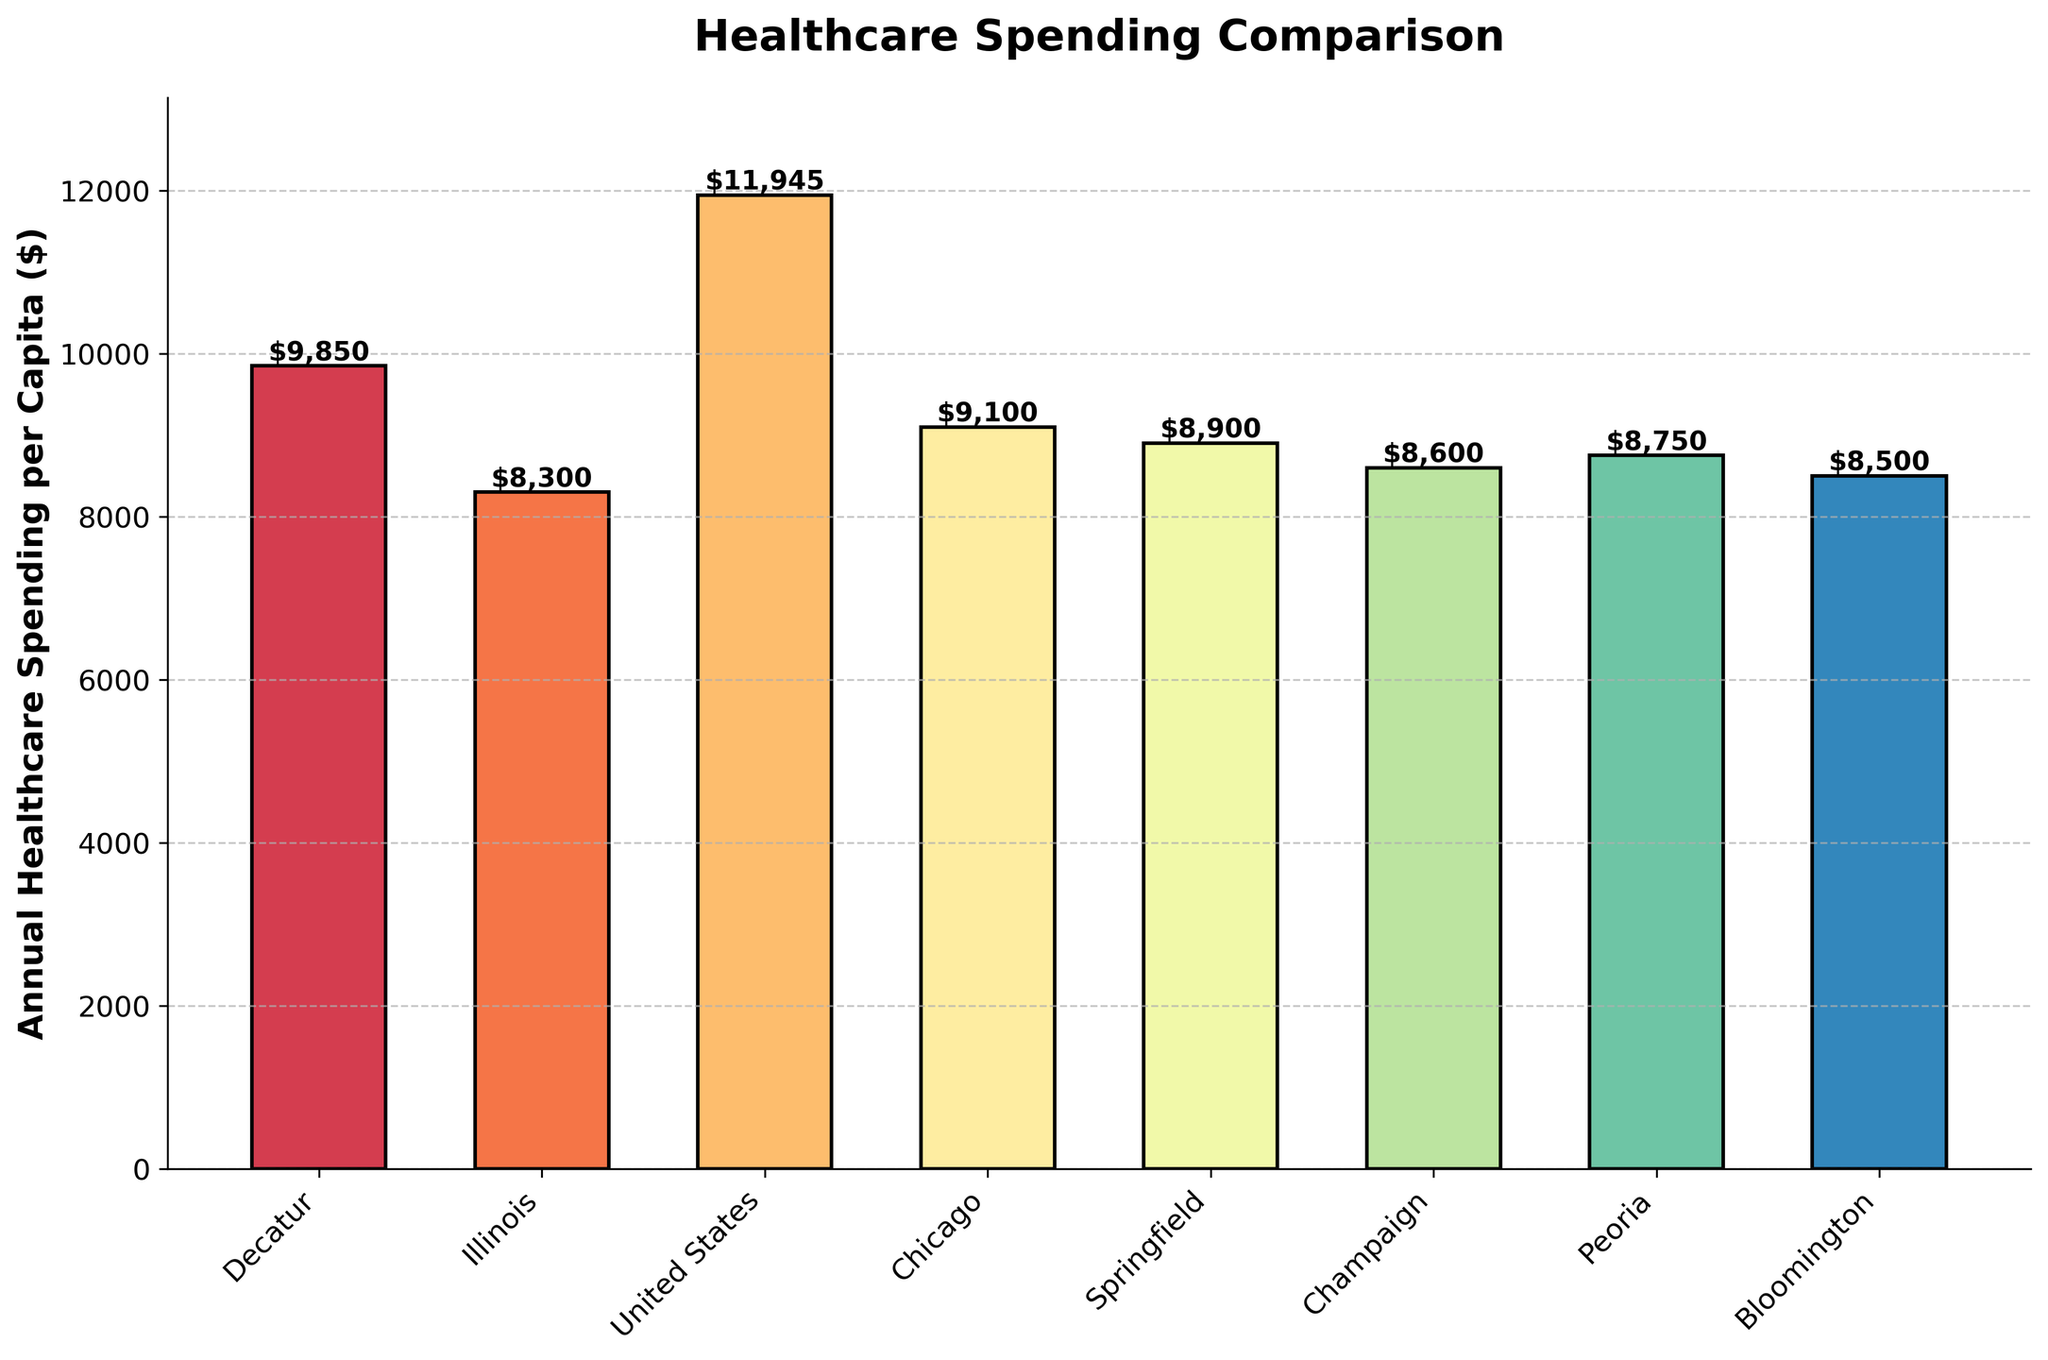What is the difference in annual healthcare spending per capita between Decatur and Illinois? To find the difference, subtract the spending in Illinois from the spending in Decatur: $9850 - $8300 = $1550
Answer: $1550 How does the annual healthcare spending per capita in Decatur compare to the national average? The spending in Decatur is $9850, while the national average is $11945. Subtract the former from the latter to find the difference: $9850 - $11945 = -$2095. Decatur spends $2095 less than the national average
Answer: $2095 less Which location has the highest annual healthcare spending per capita? By looking at the heights of the bars, the United States has the highest spending at $11945
Answer: United States What is the median annual healthcare spending per capita shown in the chart? Arrange the values in ascending order: $8300, $8500, $8600, $8750, $8900, $9100, $9850, $11945. The median value is the average of the 4th and 5th values: ($8750 + $8900)/2 = $8825
Answer: $8825 How much more does Decatur spend on healthcare per capita compared to Peoria? Subtract Peoria's spending from Decatur's: $9850 - $8750 = $1100
Answer: $1100 Which three cities have the lowest healthcare spending per capita, and what are their amounts? Comparing the heights of the bars, the three cities with the lowest spending are: Bloomington ($8500), Champaign ($8600), and Peoria ($8750)
Answer: Bloomington: $8500, Champaign: $8600, Peoria: $8750 How much does Springfield spend on healthcare per capita, and how does it compare to Chicago? Springfield spends $8900 and Chicago spends $9100. Calculate the difference: $9100 - $8900 = $200. Springfield spends $200 less than Chicago
Answer: $8900, $200 less What is the range of annual healthcare spending per capita across all the locations shown? The range is the difference between the maximum and minimum values. Maximum: $11945, Minimum: $8300. Range: $11945 - $8300 = $3645
Answer: $3645 Across all the locations, what is the difference between the average annual healthcare spending per capita and the national average? First, calculate the average of the location-specific spending (excluding the national average) and compare it. Sum the values: $9850 (Decatur) + $8300 (Illinois) + $9100 (Chicago) + $8900 (Springfield) + $8600 (Champaign) + $8750 (Peoria) + $8500 (Bloomington) = $62000. Divide by the number of locations: $62000 / 7 = $8857.14. Difference: $11945 - $8857.14 = $3087.86
Answer: $3087.86 